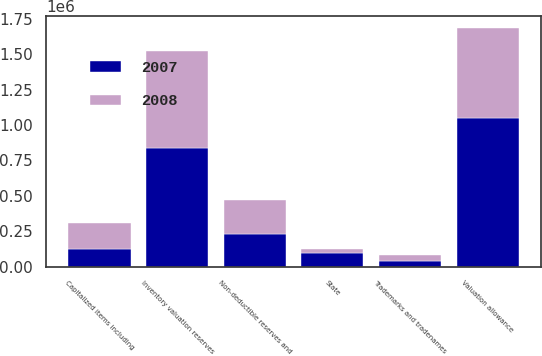Convert chart to OTSL. <chart><loc_0><loc_0><loc_500><loc_500><stacked_bar_chart><ecel><fcel>Capitalized items including<fcel>Trademarks and tradenames<fcel>Non-deductible reserves and<fcel>Inventory valuation reserves<fcel>State<fcel>Valuation allowance<nl><fcel>2007<fcel>127228<fcel>38971<fcel>230159<fcel>836145<fcel>94100<fcel>1.05167e+06<nl><fcel>2008<fcel>176995<fcel>42068<fcel>237911<fcel>689035<fcel>29907<fcel>631884<nl></chart> 